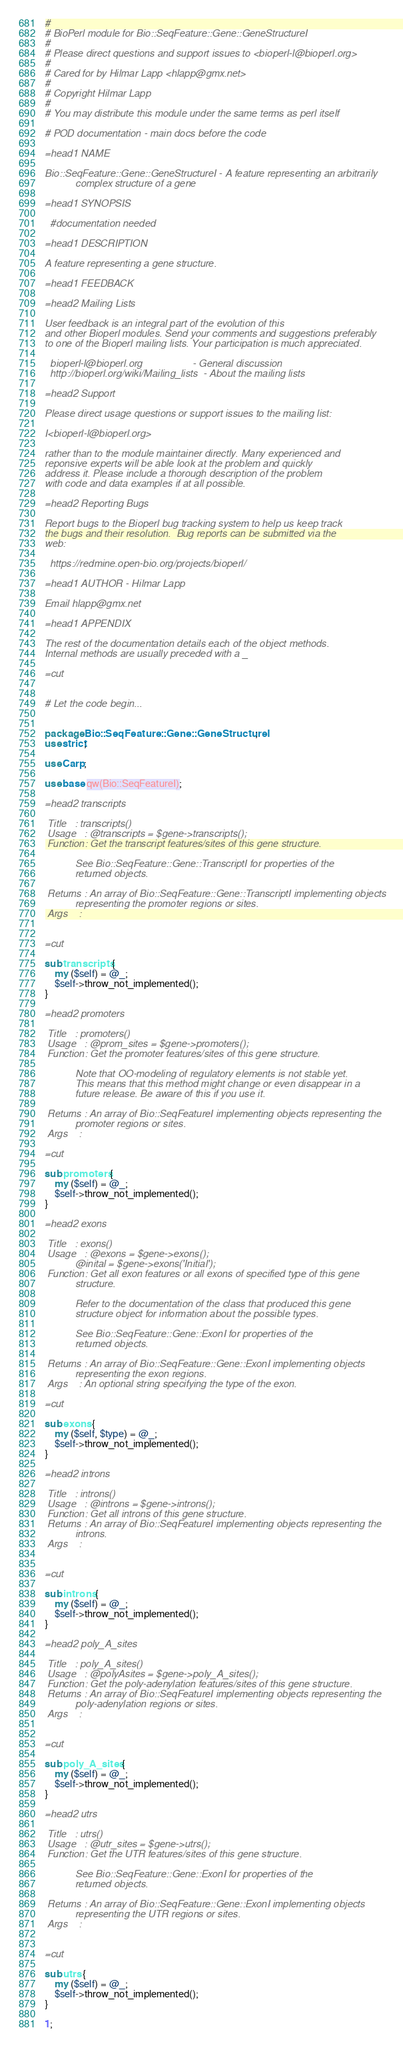Convert code to text. <code><loc_0><loc_0><loc_500><loc_500><_Perl_>#
# BioPerl module for Bio::SeqFeature::Gene::GeneStructureI
#
# Please direct questions and support issues to <bioperl-l@bioperl.org> 
#
# Cared for by Hilmar Lapp <hlapp@gmx.net>
#
# Copyright Hilmar Lapp
#
# You may distribute this module under the same terms as perl itself

# POD documentation - main docs before the code

=head1 NAME

Bio::SeqFeature::Gene::GeneStructureI - A feature representing an arbitrarily
           complex structure of a gene

=head1 SYNOPSIS

  #documentation needed

=head1 DESCRIPTION

A feature representing a gene structure.

=head1 FEEDBACK

=head2 Mailing Lists

User feedback is an integral part of the evolution of this
and other Bioperl modules. Send your comments and suggestions preferably
to one of the Bioperl mailing lists. Your participation is much appreciated.

  bioperl-l@bioperl.org                  - General discussion
  http://bioperl.org/wiki/Mailing_lists  - About the mailing lists

=head2 Support 

Please direct usage questions or support issues to the mailing list:

I<bioperl-l@bioperl.org>

rather than to the module maintainer directly. Many experienced and 
reponsive experts will be able look at the problem and quickly 
address it. Please include a thorough description of the problem 
with code and data examples if at all possible.

=head2 Reporting Bugs

Report bugs to the Bioperl bug tracking system to help us keep track
the bugs and their resolution.  Bug reports can be submitted via the
web:

  https://redmine.open-bio.org/projects/bioperl/

=head1 AUTHOR - Hilmar Lapp

Email hlapp@gmx.net

=head1 APPENDIX

The rest of the documentation details each of the object methods.
Internal methods are usually preceded with a _

=cut


# Let the code begin...


package Bio::SeqFeature::Gene::GeneStructureI;
use strict;

use Carp;

use base qw(Bio::SeqFeatureI);

=head2 transcripts

 Title   : transcripts()
 Usage   : @transcripts = $gene->transcripts();
 Function: Get the transcript features/sites of this gene structure.

           See Bio::SeqFeature::Gene::TranscriptI for properties of the
           returned objects.

 Returns : An array of Bio::SeqFeature::Gene::TranscriptI implementing objects
           representing the promoter regions or sites.
 Args    : 


=cut

sub transcripts {
    my ($self) = @_;
    $self->throw_not_implemented();
}

=head2 promoters

 Title   : promoters()
 Usage   : @prom_sites = $gene->promoters();
 Function: Get the promoter features/sites of this gene structure.

           Note that OO-modeling of regulatory elements is not stable yet.
           This means that this method might change or even disappear in a
           future release. Be aware of this if you use it.

 Returns : An array of Bio::SeqFeatureI implementing objects representing the
           promoter regions or sites.
 Args    : 

=cut

sub promoters {
    my ($self) = @_;
    $self->throw_not_implemented();
}

=head2 exons

 Title   : exons()
 Usage   : @exons = $gene->exons();
           @inital = $gene->exons('Initial');
 Function: Get all exon features or all exons of specified type of this gene
           structure.

           Refer to the documentation of the class that produced this gene
           structure object for information about the possible types.

           See Bio::SeqFeature::Gene::ExonI for properties of the
           returned objects.

 Returns : An array of Bio::SeqFeature::Gene::ExonI implementing objects
           representing the exon regions.
 Args    : An optional string specifying the type of the exon.

=cut

sub exons {
    my ($self, $type) = @_;
    $self->throw_not_implemented();
}

=head2 introns

 Title   : introns()
 Usage   : @introns = $gene->introns();
 Function: Get all introns of this gene structure.
 Returns : An array of Bio::SeqFeatureI implementing objects representing the
           introns.
 Args    : 


=cut

sub introns {
    my ($self) = @_;
    $self->throw_not_implemented();
}

=head2 poly_A_sites

 Title   : poly_A_sites()
 Usage   : @polyAsites = $gene->poly_A_sites();
 Function: Get the poly-adenylation features/sites of this gene structure.
 Returns : An array of Bio::SeqFeatureI implementing objects representing the
           poly-adenylation regions or sites.
 Args    : 


=cut

sub poly_A_sites {
    my ($self) = @_;
    $self->throw_not_implemented();
}

=head2 utrs

 Title   : utrs()
 Usage   : @utr_sites = $gene->utrs();
 Function: Get the UTR features/sites of this gene structure.

           See Bio::SeqFeature::Gene::ExonI for properties of the
           returned objects.

 Returns : An array of Bio::SeqFeature::Gene::ExonI implementing objects
           representing the UTR regions or sites.
 Args    : 


=cut

sub utrs {
    my ($self) = @_;
    $self->throw_not_implemented();
}

1;
</code> 